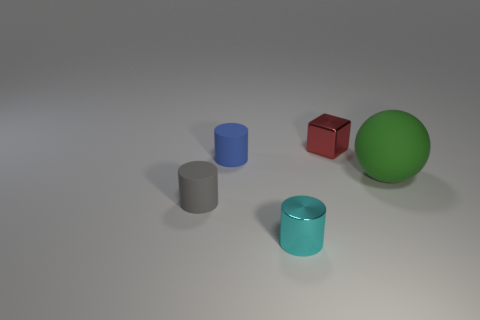Add 5 large blue shiny things. How many objects exist? 10 Subtract all metallic cylinders. How many cylinders are left? 2 Add 5 green matte objects. How many green matte objects are left? 6 Add 5 large brown rubber cylinders. How many large brown rubber cylinders exist? 5 Subtract all blue cylinders. How many cylinders are left? 2 Subtract 1 green spheres. How many objects are left? 4 Subtract all cylinders. How many objects are left? 2 Subtract 1 balls. How many balls are left? 0 Subtract all purple cylinders. Subtract all red cubes. How many cylinders are left? 3 Subtract all brown cylinders. How many gray spheres are left? 0 